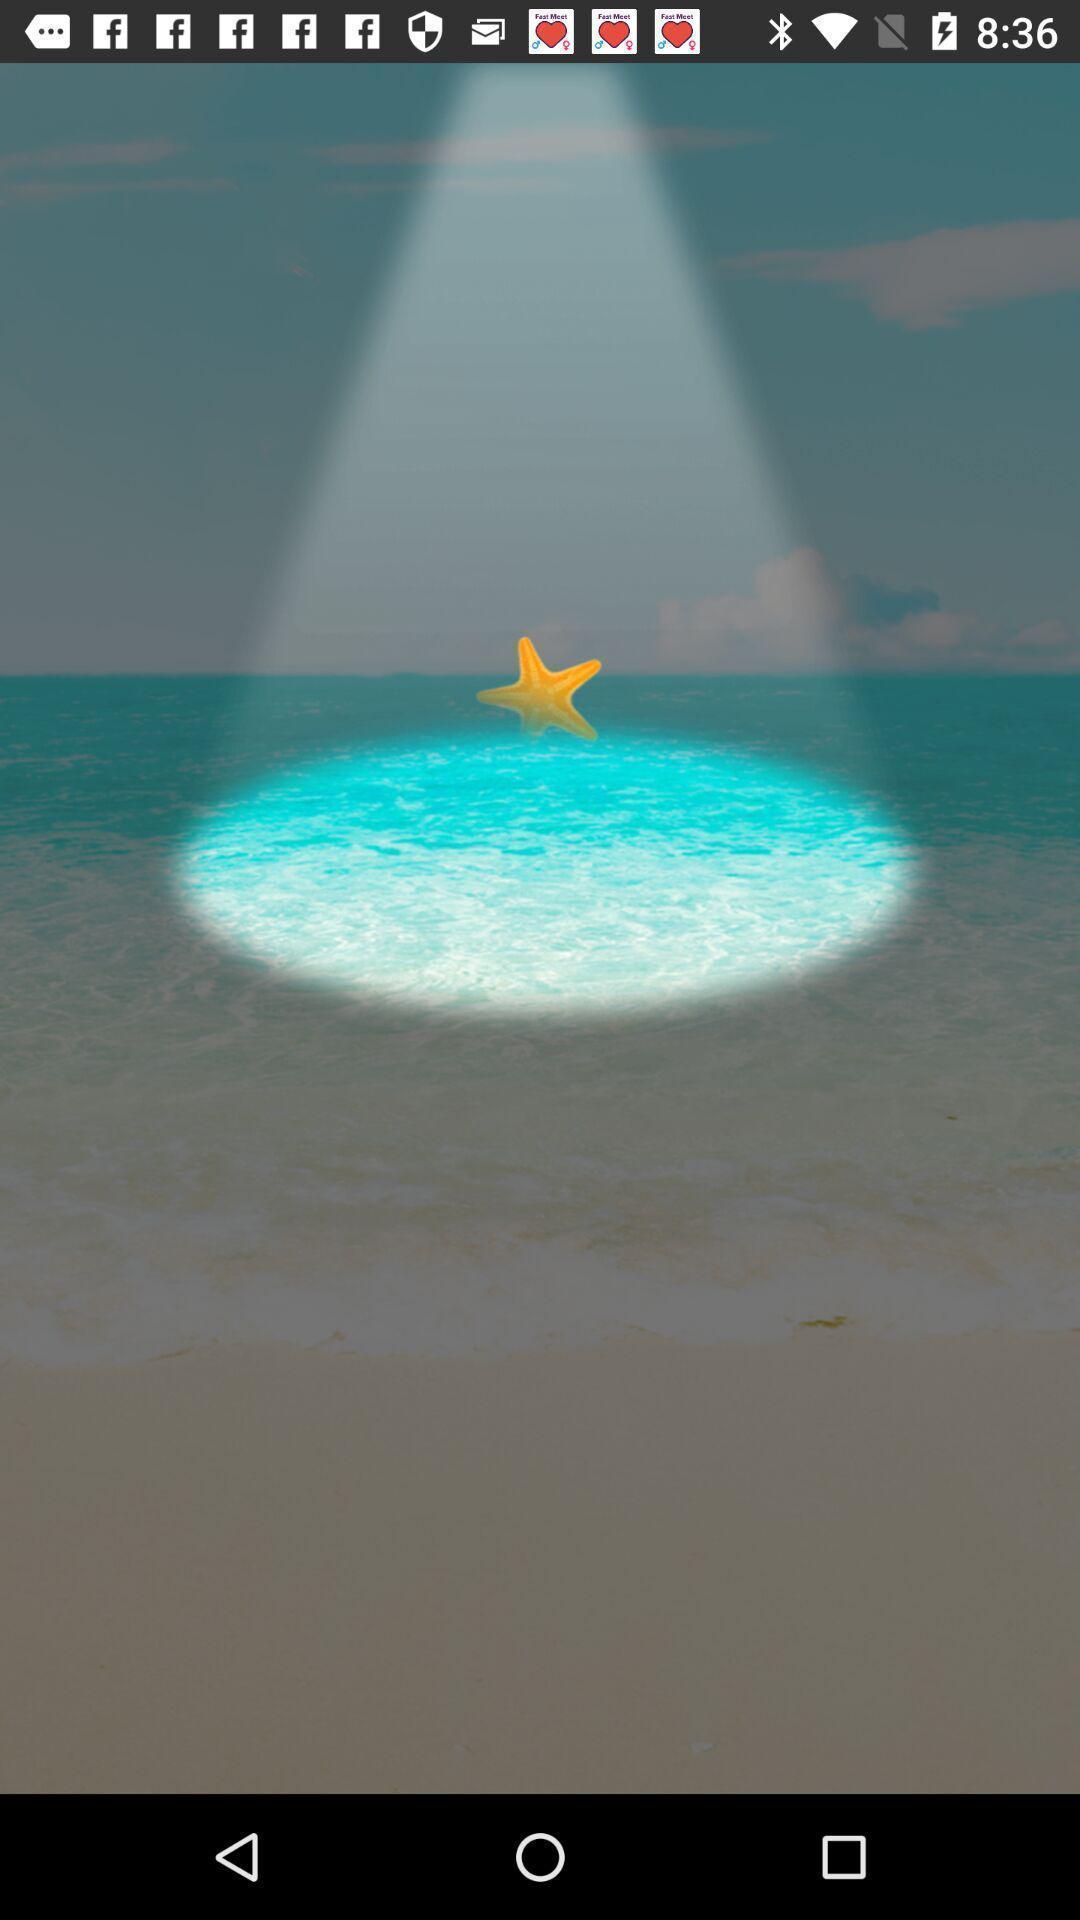Describe the key features of this screenshot. Screen displaying an image on a device. 